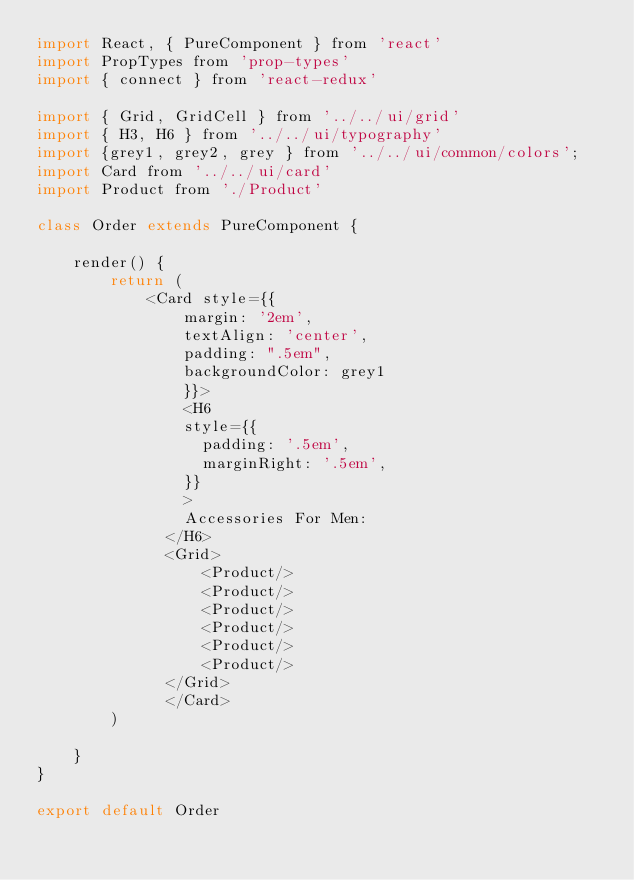Convert code to text. <code><loc_0><loc_0><loc_500><loc_500><_JavaScript_>import React, { PureComponent } from 'react'
import PropTypes from 'prop-types'
import { connect } from 'react-redux'

import { Grid, GridCell } from '../../ui/grid'
import { H3, H6 } from '../../ui/typography'
import {grey1, grey2, grey } from '../../ui/common/colors';
import Card from '../../ui/card'
import Product from './Product'

class Order extends PureComponent {

    render() {
        return (
            <Card style={{ 
                margin: '2em', 
                textAlign: 'center', 
                padding: ".5em",
                backgroundColor: grey1
                }}>
                <H6
                style={{
                  padding: '.5em',
                  marginRight: '.5em',
                }}
                >
                Accessories For Men:
              </H6>
              <Grid>
                  <Product/>
                  <Product/>
                  <Product/>
                  <Product/>
                  <Product/>
                  <Product/>
              </Grid>
              </Card>
        )
        
    }
}

export default Order</code> 